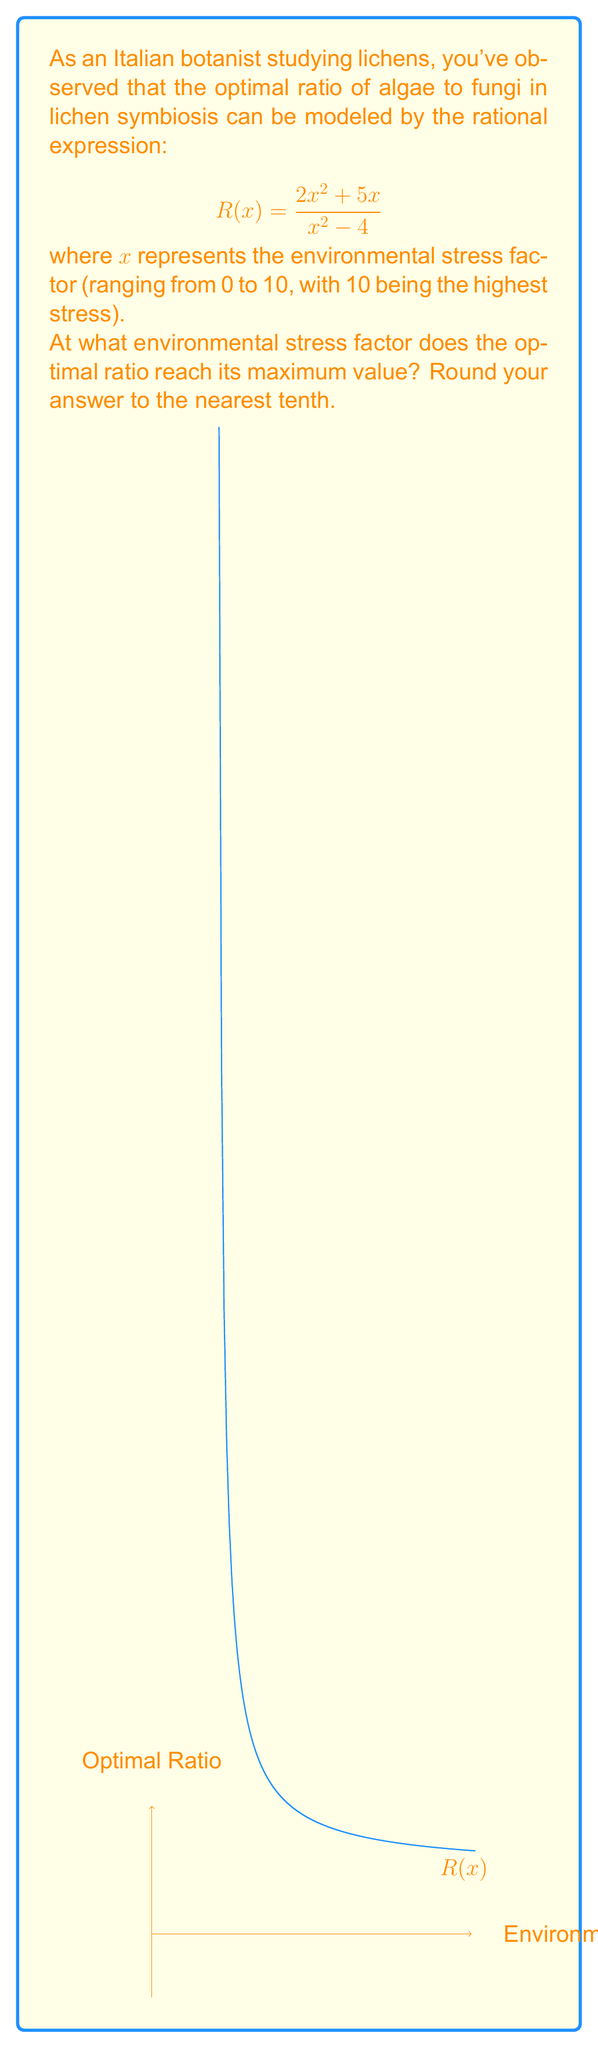Could you help me with this problem? Let's approach this step-by-step:

1) To find the maximum value of a rational function, we need to find where its derivative equals zero.

2) The derivative of $R(x)$ is:

   $$R'(x) = \frac{(2x^2 + 5x)'(x^2 - 4) - (2x^2 + 5x)(x^2 - 4)'}{(x^2 - 4)^2}$$

3) Simplifying:

   $$R'(x) = \frac{(4x + 5)(x^2 - 4) - (2x^2 + 5x)(2x)}{(x^2 - 4)^2}$$

4) Expanding the numerator:

   $$R'(x) = \frac{4x^3 - 16x + 5x^2 - 20 - 4x^3 - 10x^2}{(x^2 - 4)^2}$$

5) Simplifying further:

   $$R'(x) = \frac{-5x^2 - 16x - 20}{(x^2 - 4)^2}$$

6) For the maximum, set $R'(x) = 0$:

   $$\frac{-5x^2 - 16x - 20}{(x^2 - 4)^2} = 0$$

7) The denominator is always positive for $x \neq \pm 2$, so we solve:

   $$-5x^2 - 16x - 20 = 0$$

8) This is a quadratic equation. Using the quadratic formula:

   $$x = \frac{-b \pm \sqrt{b^2 - 4ac}}{2a}$$

   Where $a = -5$, $b = -16$, and $c = -20$

9) Substituting:

   $$x = \frac{16 \pm \sqrt{(-16)^2 - 4(-5)(-20)}}{2(-5)}$$

   $$x = \frac{16 \pm \sqrt{256 - 400}}{-10} = \frac{16 \pm \sqrt{-144}}{-10}$$

10) Since we can't have a negative under the square root, there's only one real solution:

    $$x = \frac{16}{-10} = -1.6$$

11) However, our domain is [0, 10], so this solution is not valid.

12) This means the maximum must occur at one of the endpoints of our domain.

13) Evaluating $R(0)$ and $R(10)$:

    $R(0)$ is undefined
    $R(10) = \frac{250}{96} \approx 2.60$

Therefore, the maximum occurs at $x = 10$.
Answer: 10 